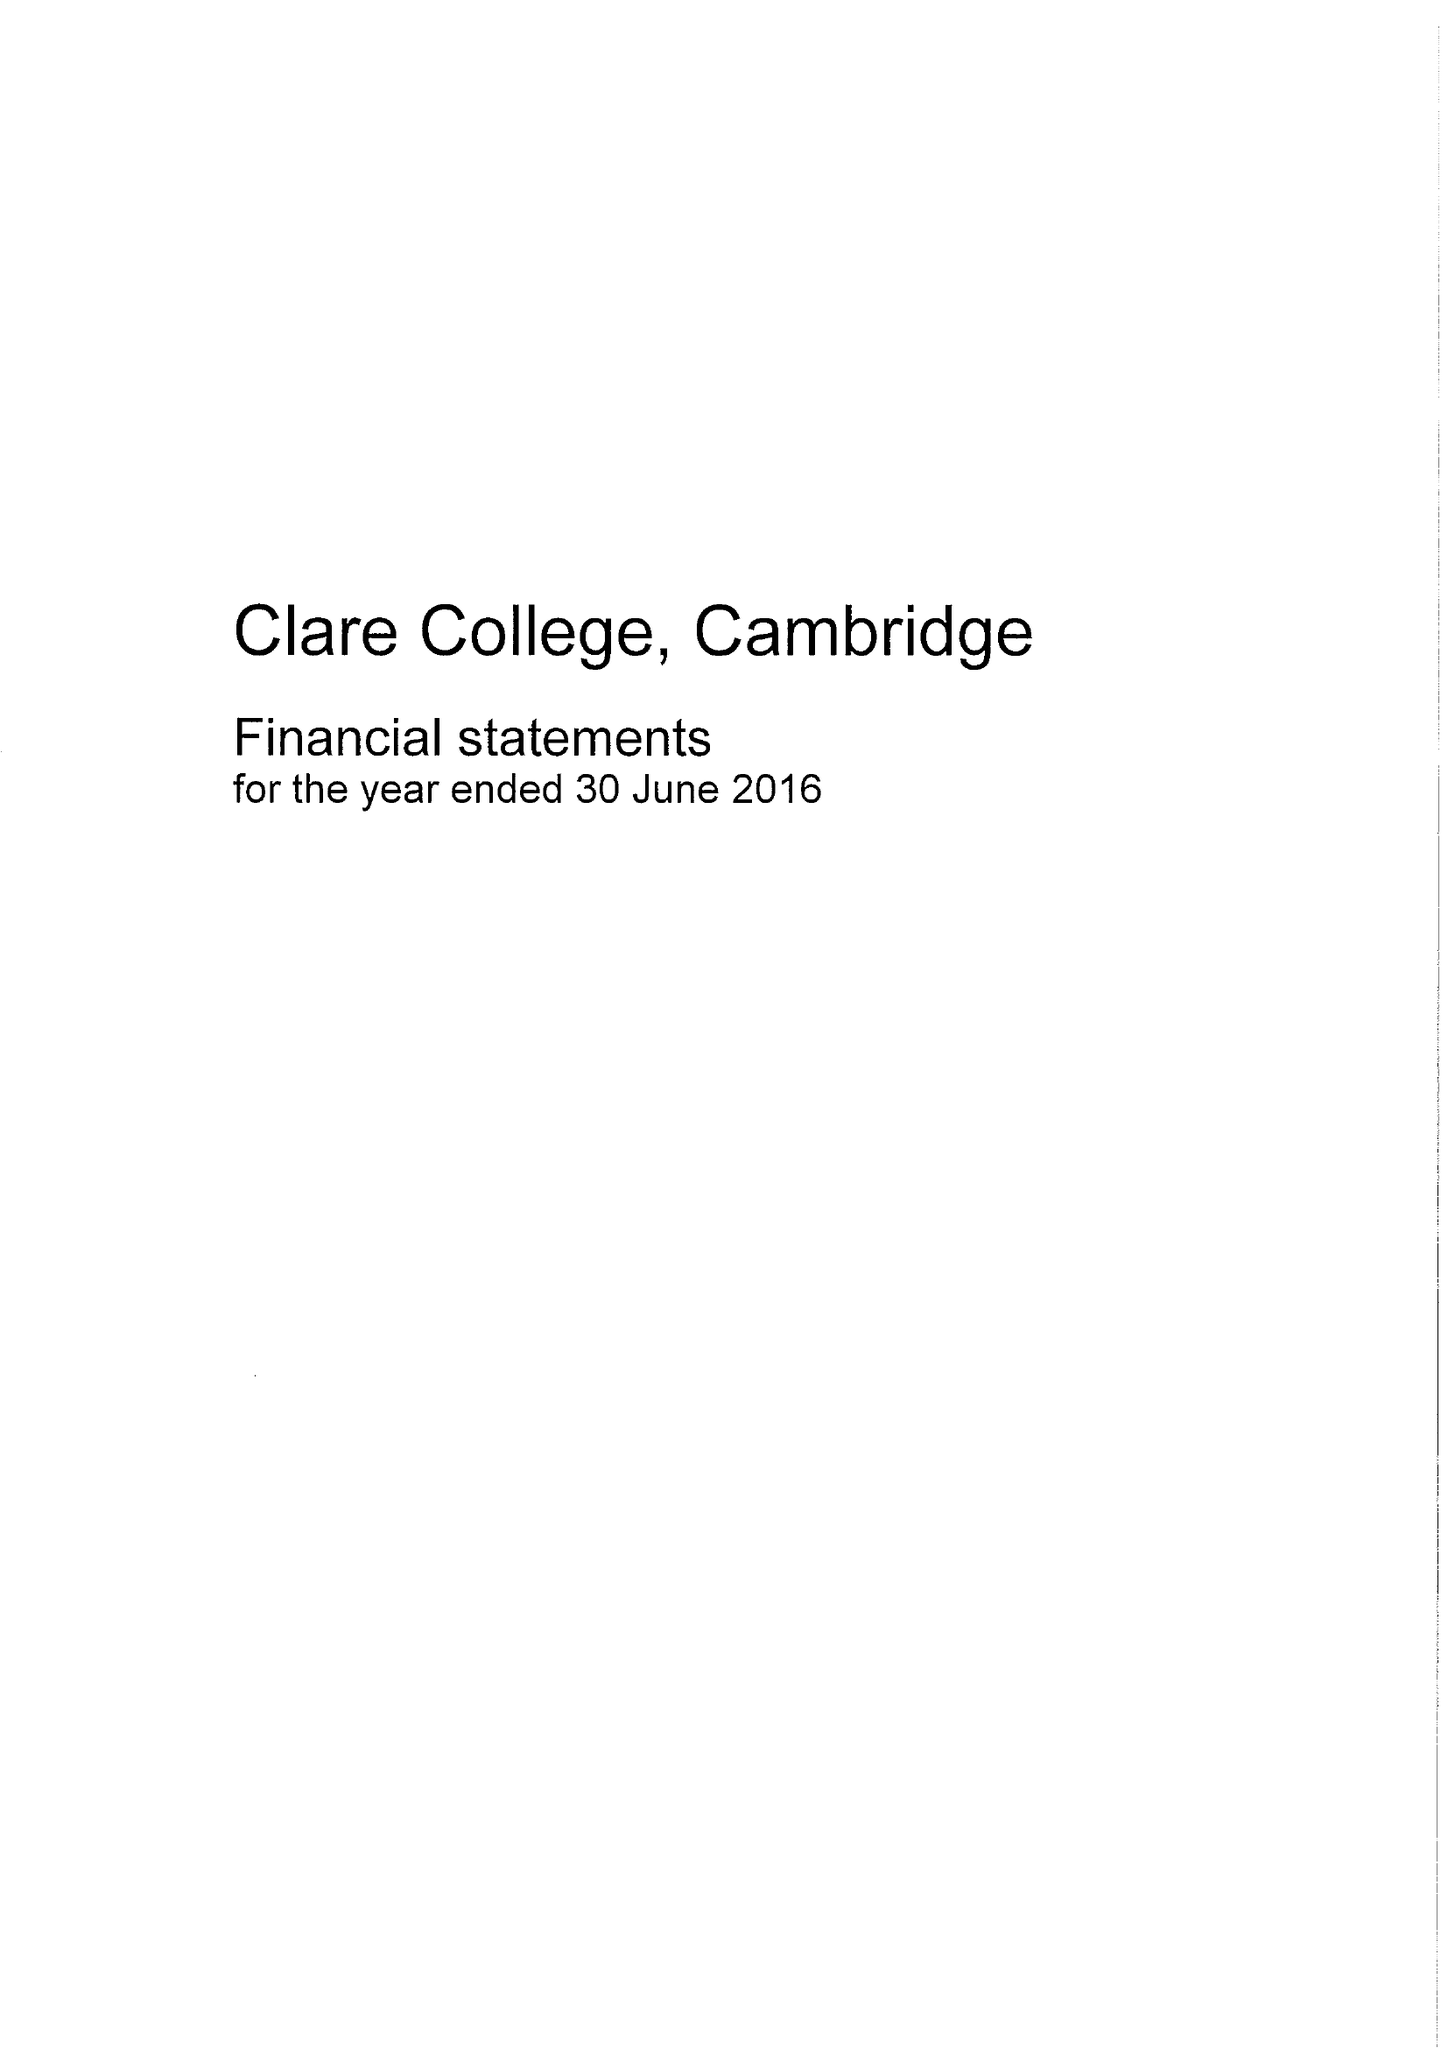What is the value for the address__street_line?
Answer the question using a single word or phrase. TRINITY LANE 